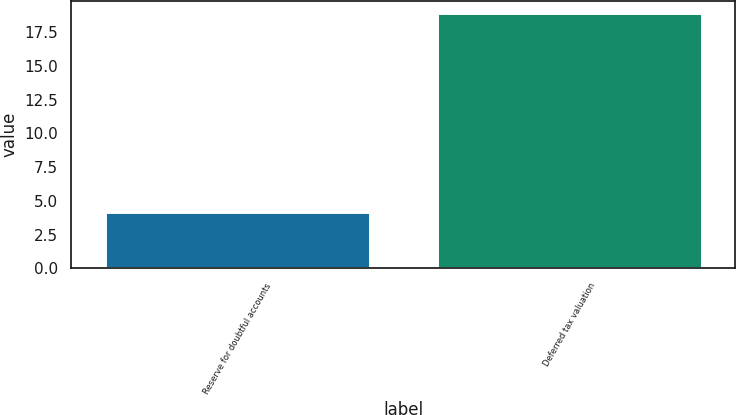Convert chart to OTSL. <chart><loc_0><loc_0><loc_500><loc_500><bar_chart><fcel>Reserve for doubtful accounts<fcel>Deferred tax valuation<nl><fcel>4.2<fcel>18.9<nl></chart> 